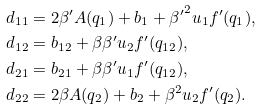<formula> <loc_0><loc_0><loc_500><loc_500>d _ { 1 1 } & = 2 \beta ^ { \prime } A ( q _ { 1 } ) + b _ { 1 } + { \beta ^ { \prime } } ^ { 2 } u _ { 1 } f ^ { \prime } ( q _ { 1 } ) , \\ d _ { 1 2 } & = b _ { 1 2 } + \beta \beta ^ { \prime } u _ { 2 } f ^ { \prime } ( q _ { 1 2 } ) , \\ d _ { 2 1 } & = b _ { 2 1 } + \beta \beta ^ { \prime } u _ { 1 } f ^ { \prime } ( q _ { 1 2 } ) , \\ d _ { 2 2 } & = 2 \beta A ( q _ { 2 } ) + b _ { 2 } + \beta ^ { 2 } u _ { 2 } f ^ { \prime } ( q _ { 2 } ) .</formula> 